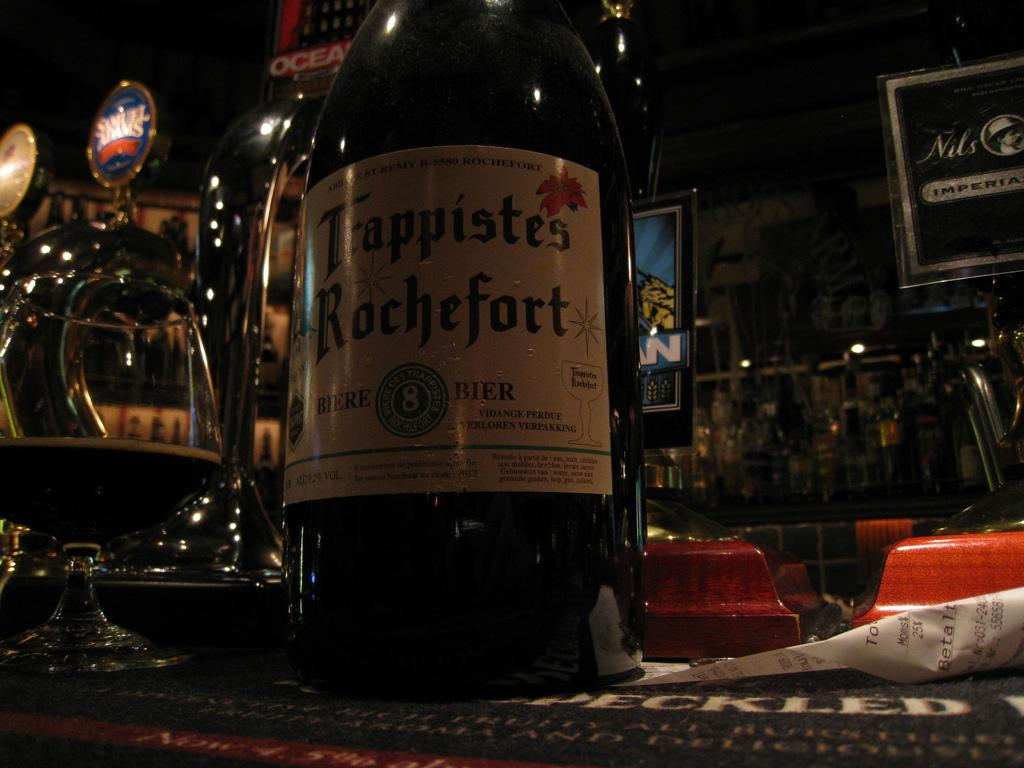Provide a one-sentence caption for the provided image. Trappistes Rochefort is the name on the label of this liquor bottle. 